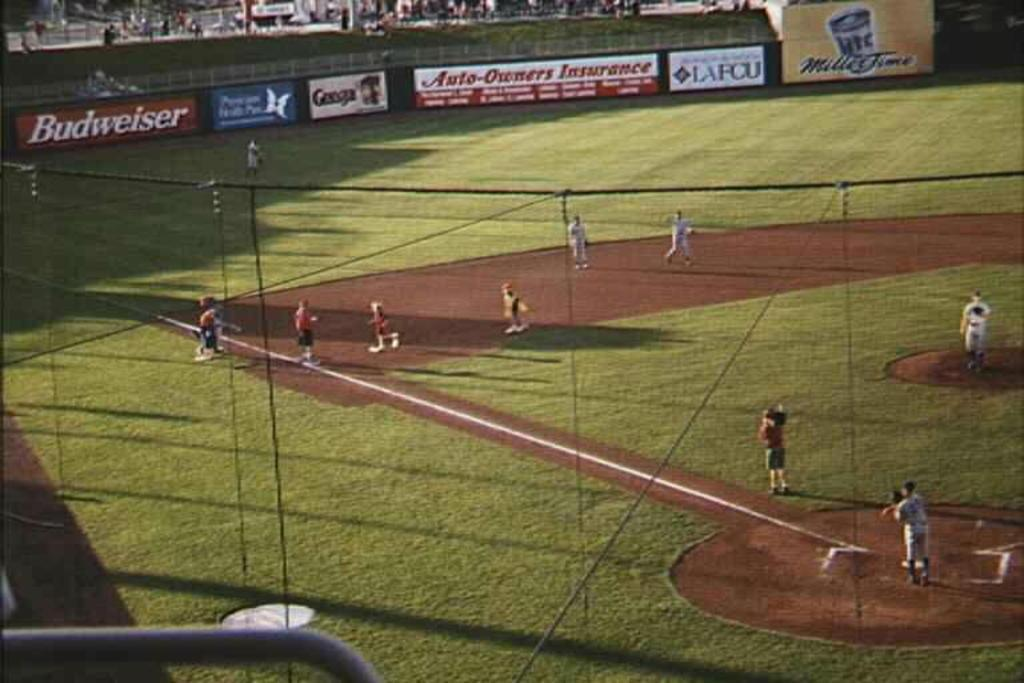What is the main subject of the image? The main subject of the image is a group of people standing. What can be seen in the background of the image? There are boards and grass visible in the background. What type of fencing is present in the image? There are iron grills in the image. What other items can be found in the image? There are other items present in the image, but their specific nature is not mentioned in the provided facts. What type of brass instrument is being played by the woman in the image? There is no woman or brass instrument present in the image. 